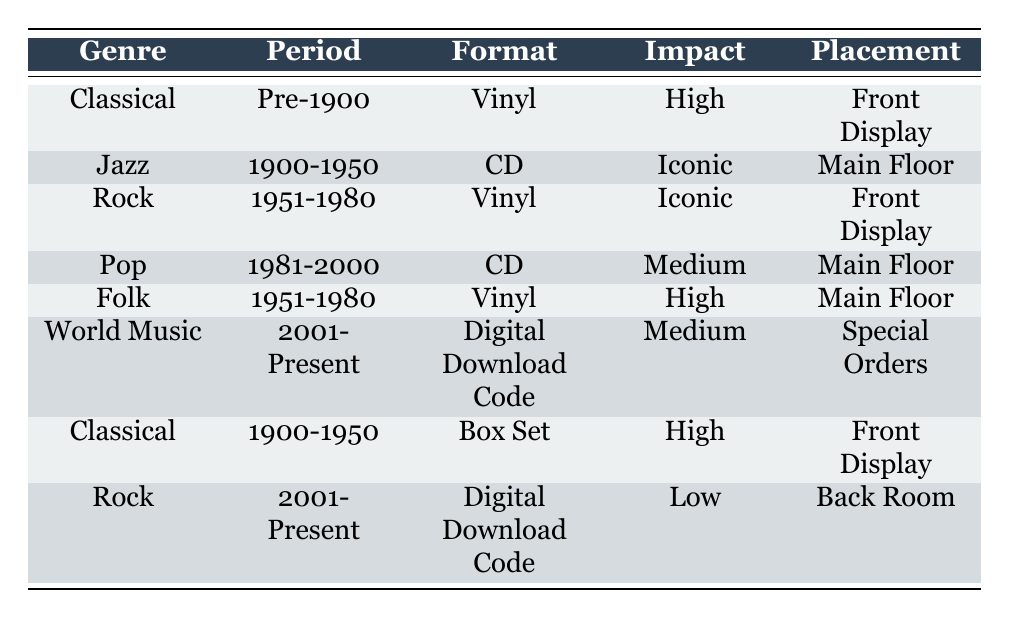What genre has the highest cultural impact? By examining the "Impact" column in the table, the genres with "High" and "Iconic" impact levels are "Classical" (Pre-1900, Vinyl), "Jazz" (1900-1950, CD), "Rock" (1951-1980, Vinyl), and "Folk" (1951-1980, Vinyl), and "Classical" (1900-1950, Box Set) as well as "Rock" (1951-1980, Vinyl). Among these, "Jazz" is categorized as "Iconic," making it the genre with the highest cultural impact.
Answer: Jazz Which format type is used for the "World Music" genre? The row that depicts the "World Music" genre shows its format type as "Digital Download Code." This can be found under the "Format" column for the corresponding genre row in the table.
Answer: Digital Download Code Is there any genre from the 2001-Present period that is stored in the Front Display? The "Front Display" placement is found under the "Placement" column, and checking the relevant rows reveals that only the "World Music" genre (2001-Present) is placed there, while other genres from this period are categorized differently.
Answer: No How many genres have a "Vinyl" format, and what are they? Looking at the "Format" column, we count "Vinyl" entries in the table. The genres with this format are "Classical" (Pre-1900), "Rock" (1951-1980), and "Folk" (1951-1980). Therefore, there are three genres that utilize the "Vinyl" format.
Answer: 3 genres: Classical, Rock, Folk What is the placement for the "Pop" genre? Observing the "Pop" genre in the table, we find its placement in the "Placement" column, which explicitly states "Main Floor." Therefore, this information directly answers the question.
Answer: Main Floor How many genres are categorized as "Iconic"? The table lists genres such as "Jazz" (1900-1950, CD) and "Rock" (1951-1980, Vinyl) with "Iconic" impact. By counting these instances, we identify a total of two genres classified as "Iconic."
Answer: 2 genres 